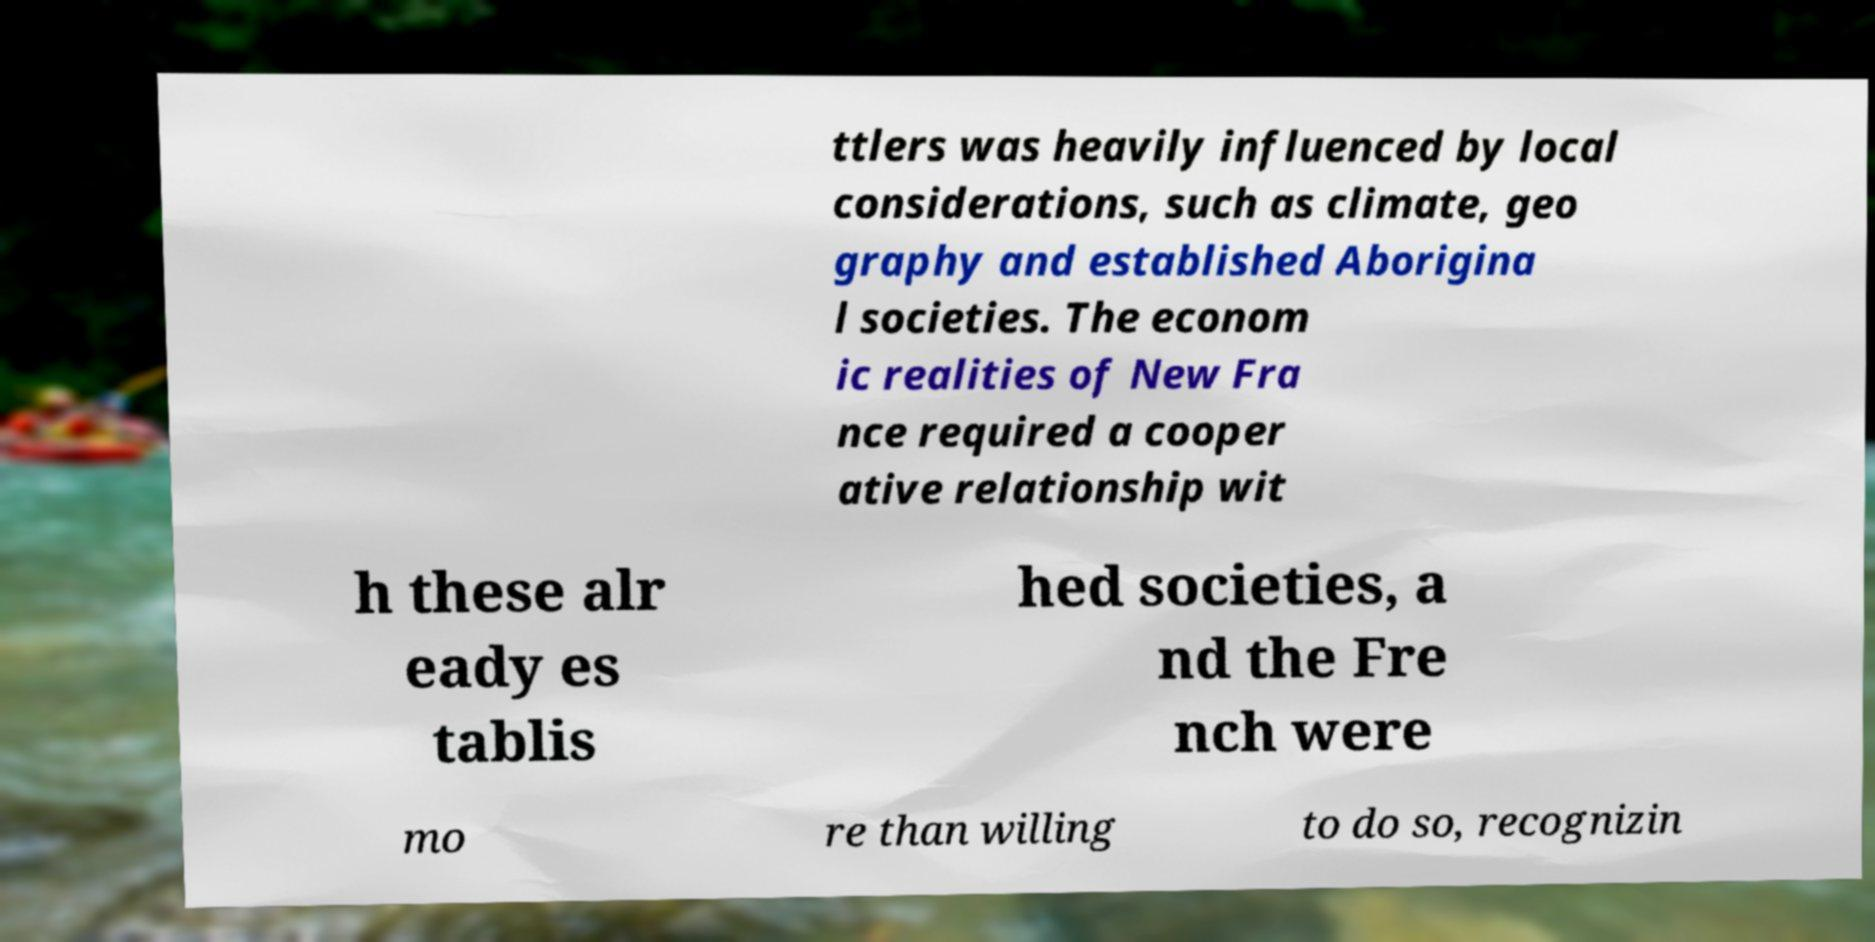Could you assist in decoding the text presented in this image and type it out clearly? ttlers was heavily influenced by local considerations, such as climate, geo graphy and established Aborigina l societies. The econom ic realities of New Fra nce required a cooper ative relationship wit h these alr eady es tablis hed societies, a nd the Fre nch were mo re than willing to do so, recognizin 